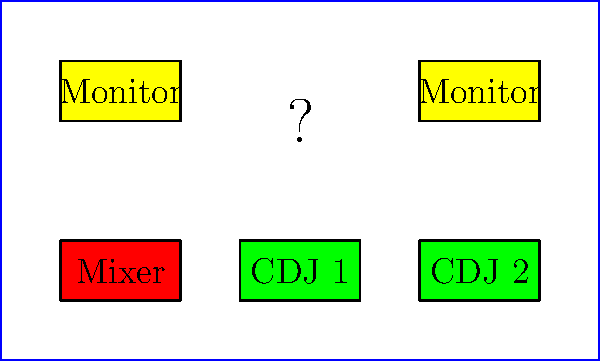A new piece of equipment needs to be added to your DJ setup on the club stage. Given the current arrangement of your mixer, CDJs, and monitors, what is the optimal location for placing a new effects unit with dimensions 2m x 1m to maintain an efficient workflow and balanced stage layout? To determine the optimal location for the new effects unit, let's analyze the current setup and consider the principles of efficient DJ workflow:

1. The mixer is centrally located at the front of the stage, which is ideal for easy access.
2. The CDJs are placed on either side of the mixer, allowing for smooth transitions between tracks.
3. Monitors are positioned at the back corners of the stage for clear sound monitoring.

Given these observations, the optimal location for the new effects unit should:
a) Be easily accessible from the mixer position
b) Not interfere with the existing equipment
c) Maintain a balanced stage layout

The space directly above the mixer (center-back of the stage) is currently unoccupied and meets all these criteria:

1. It's easily reachable from the mixer position.
2. It doesn't interfere with the CDJs or monitors.
3. It maintains symmetry and balance in the stage layout.

The dimensions of the effects unit (2m x 1m) would fit perfectly in this space, centered above the mixer.

Placing the effects unit here allows the DJ to:
- Quickly access effects while mixing
- Maintain a clear line of sight to all equipment
- Preserve the ergonomic flow of the existing setup

Therefore, the optimal location for the new effects unit is centered at coordinates (5,4) on the stage diagram, directly above the mixer.
Answer: Centered above the mixer at (5,4) 